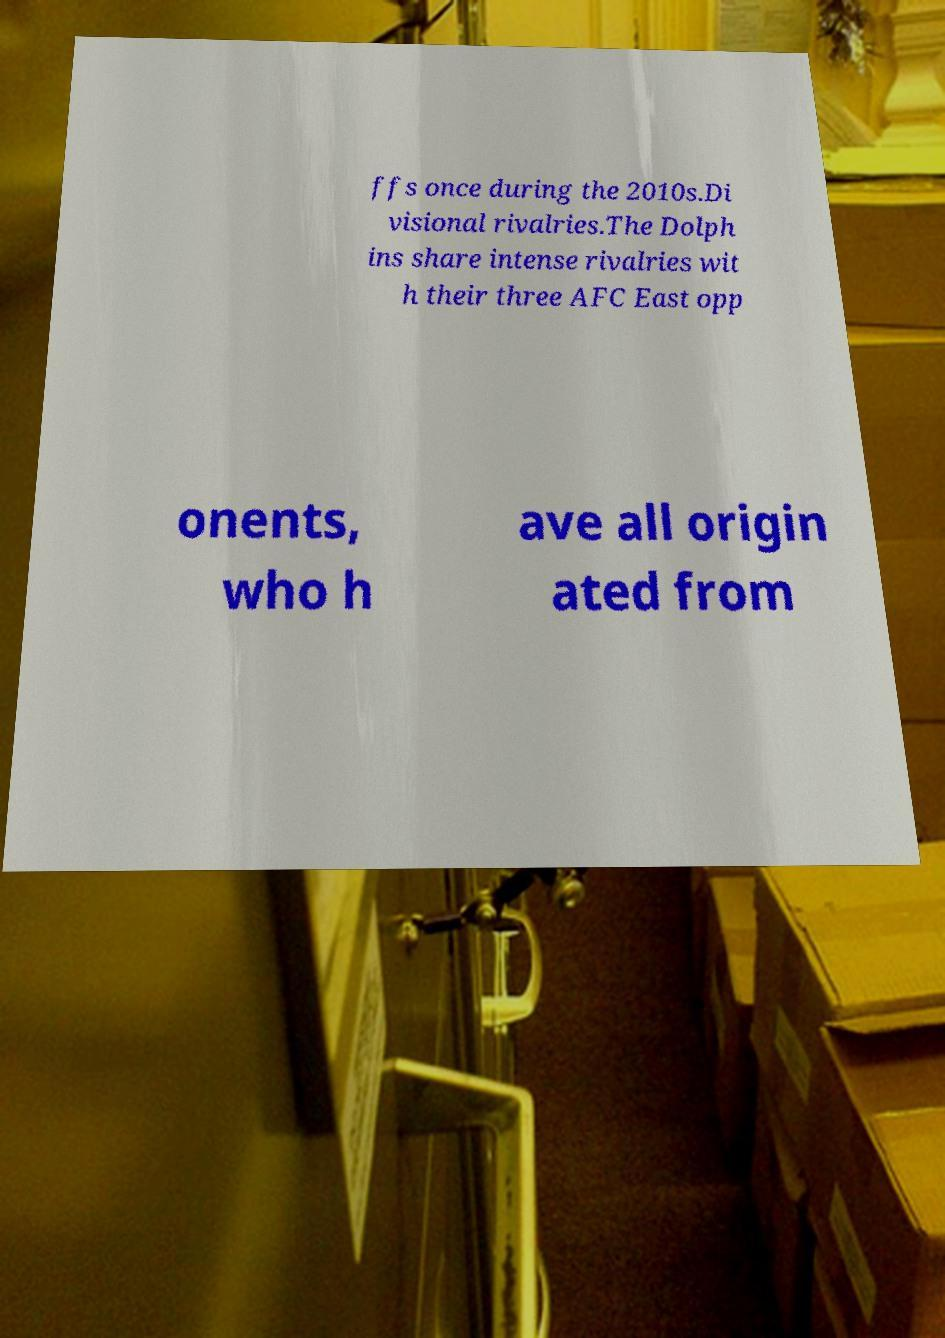Please identify and transcribe the text found in this image. ffs once during the 2010s.Di visional rivalries.The Dolph ins share intense rivalries wit h their three AFC East opp onents, who h ave all origin ated from 